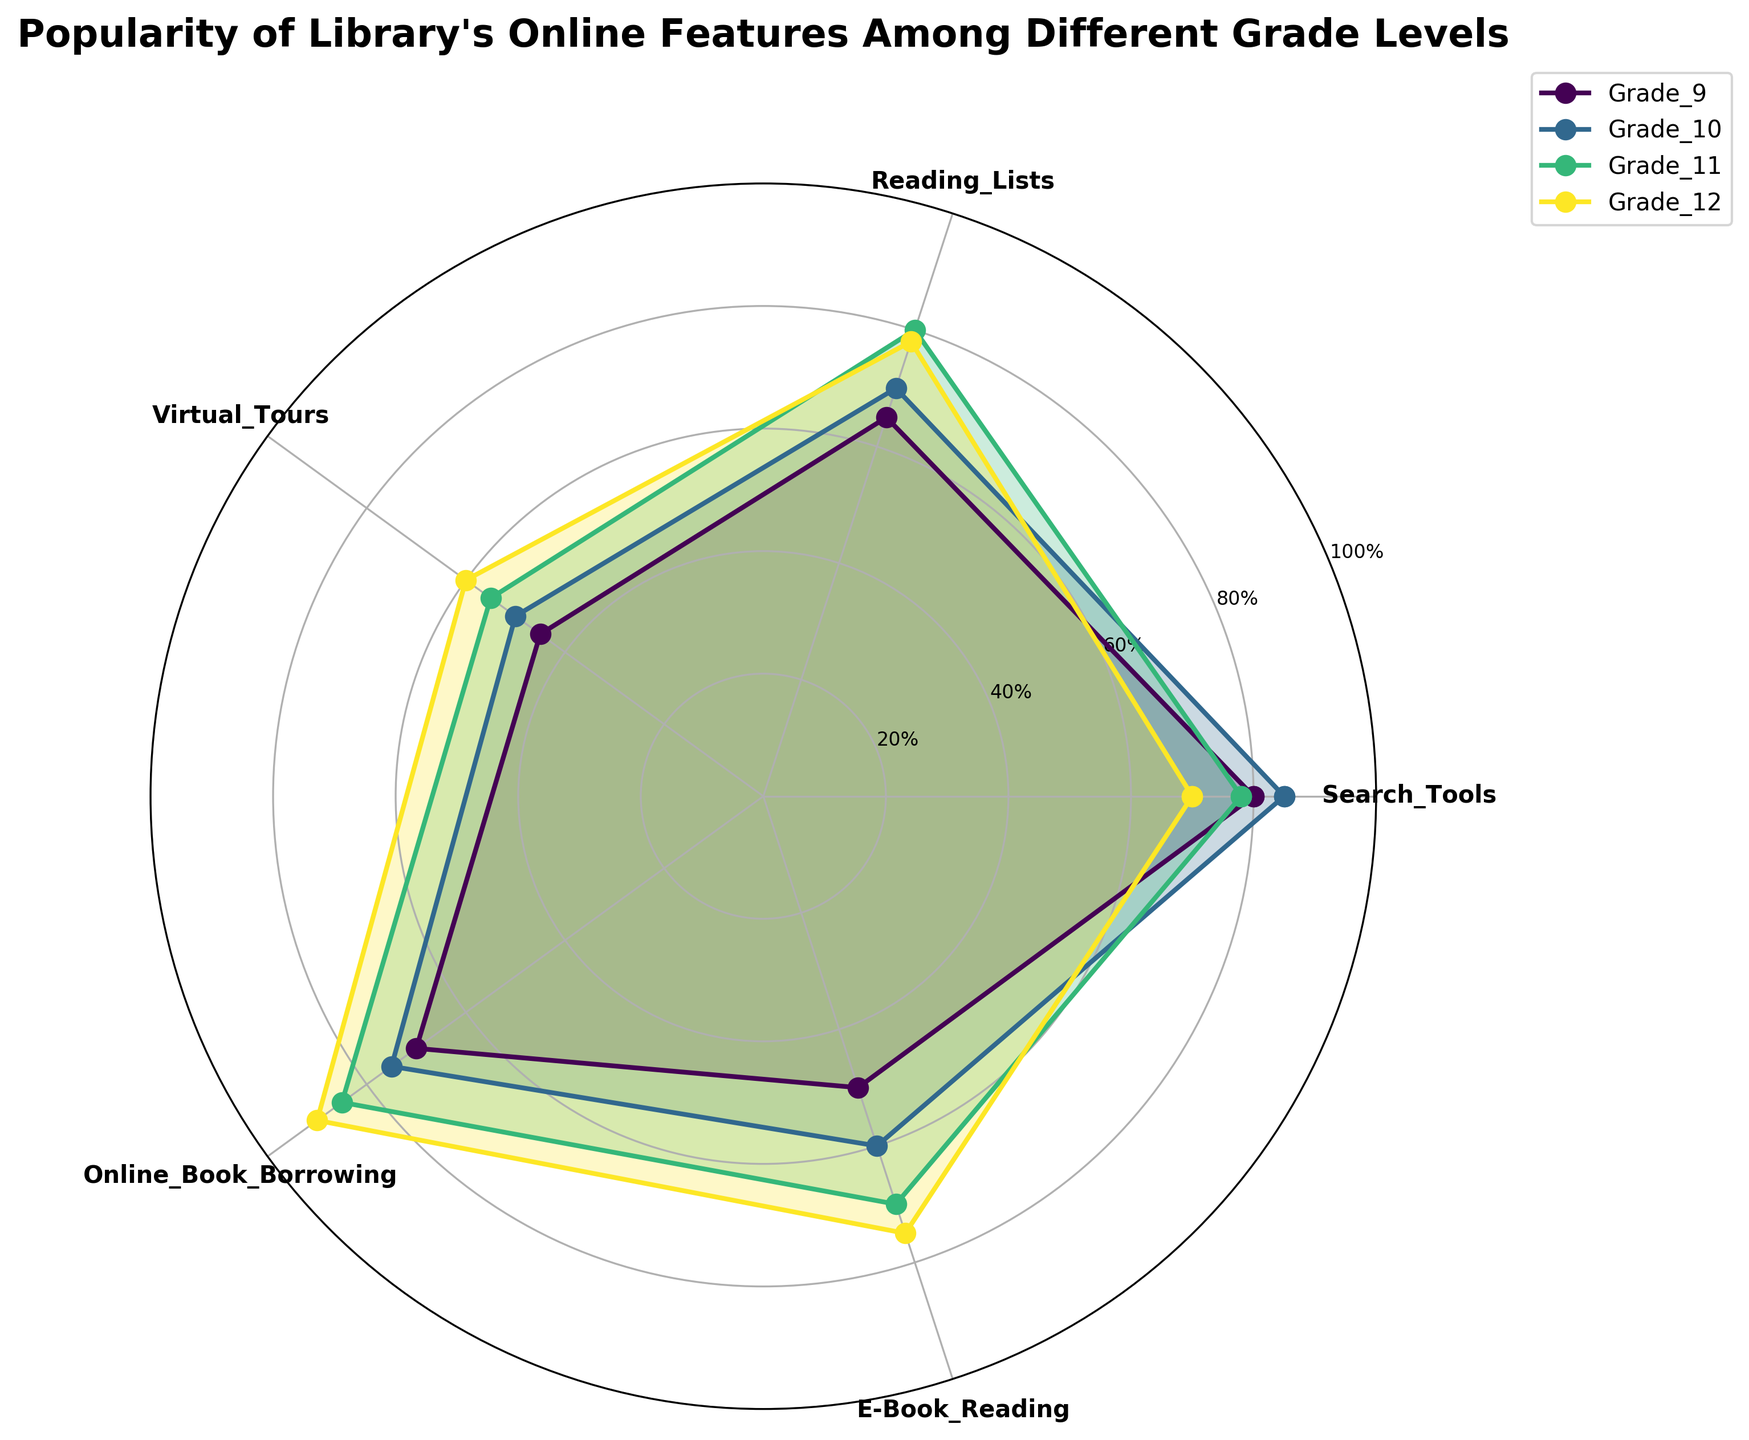What is the title of the chart? The title of the chart is displayed at the top of the figure as "Popularity of Library's Online Features Among Different Grade Levels."
Answer: Popularity of Library's Online Features Among Different Grade Levels Which grade level has the highest usage of Virtual Tours? Look at the section labeled "Virtual Tours" and compare the radial values for each grade level. Grade 12 reaches the highest value.
Answer: Grade 12 What is the feature with the lowest popularity among Grade 9 students? Look at the radial values for Grade 9 (indicated by its color) and identify the feature with the shortest value. Virtual Tours has the lowest value.
Answer: Virtual Tours How many features are compared in the chart? Count the number of segments (features) around the chart. There are five segments, corresponding to search tools, reading lists, virtual tours, online book borrowing, and e-book reading.
Answer: Five Which feature shows an increasing trend in usage from Grade 9 to Grade 12? Compare the radial values for each grade from Grade 9 to Grade 12 for each feature. Online Book Borrowing shows a consistent increase in usage across all grades.
Answer: Online Book Borrowing What is the average popularity of Reading Lists among all the grades? Find the radial values for Reading Lists for each grade and calculate the average: (65 + 70 + 80 + 78) / 4 = 73.25.
Answer: 73.25 Which grade level shows the least variability in their usage of all features? Evaluate the range of radial values for each grade level. Grade 9 has the least variability as their values are closer to each other compared to other grades.
Answer: Grade 9 What percentage of Grade 11 students prefers E-Book Reading over Virtual Tours? Compare the radial values for Grade 11 between E-Book Reading (70) and Virtual Tours (55), and calculate the percentage increase: ((70 - 55) / 55) * 100 = ~27.27%.
Answer: ~27.27% How does the popularity of Search Tools compare between Grade 9 and Grade 12? Look at the radial values for Search Tools for Grade 9 (80) and Grade 12 (70). The value for Grade 9 is higher than Grade 12.
Answer: Grade 9 is higher What feature is equally popular among Grade 10 and Grade 11 students? Identify features where the radial values are similar for Grade 10 and Grade 11: Search Tools (85 for Grade 10 and 78 for Grade 11) and Reading Lists (70 for Grade 10 and 80 for Grade 11) are not too far, but not exactly equal. None of the features have exactly equal popularity.
Answer: None 